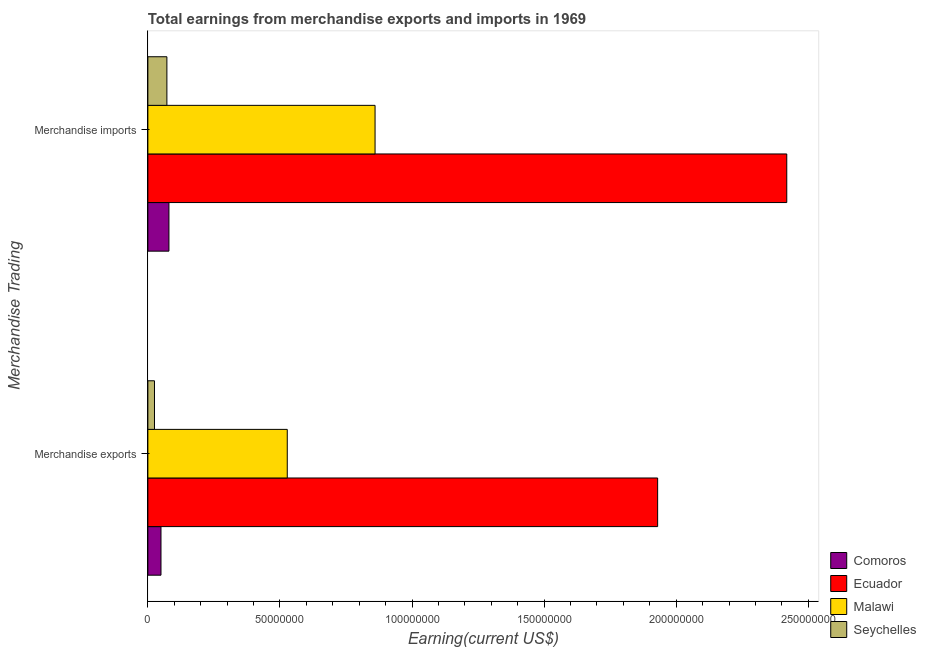How many different coloured bars are there?
Provide a short and direct response. 4. How many groups of bars are there?
Make the answer very short. 2. Are the number of bars on each tick of the Y-axis equal?
Provide a short and direct response. Yes. What is the earnings from merchandise imports in Malawi?
Provide a short and direct response. 8.60e+07. Across all countries, what is the maximum earnings from merchandise imports?
Your answer should be very brief. 2.42e+08. Across all countries, what is the minimum earnings from merchandise exports?
Offer a terse response. 2.50e+06. In which country was the earnings from merchandise imports maximum?
Ensure brevity in your answer.  Ecuador. In which country was the earnings from merchandise imports minimum?
Provide a short and direct response. Seychelles. What is the total earnings from merchandise exports in the graph?
Offer a very short reply. 2.53e+08. What is the difference between the earnings from merchandise exports in Malawi and that in Ecuador?
Provide a succinct answer. -1.40e+08. What is the difference between the earnings from merchandise imports in Ecuador and the earnings from merchandise exports in Comoros?
Provide a succinct answer. 2.37e+08. What is the average earnings from merchandise exports per country?
Offer a very short reply. 6.33e+07. What is the difference between the earnings from merchandise imports and earnings from merchandise exports in Malawi?
Ensure brevity in your answer.  3.32e+07. In how many countries, is the earnings from merchandise imports greater than 120000000 US$?
Your answer should be compact. 1. What is the ratio of the earnings from merchandise exports in Malawi to that in Comoros?
Give a very brief answer. 10.63. Is the earnings from merchandise imports in Ecuador less than that in Seychelles?
Make the answer very short. No. What does the 3rd bar from the top in Merchandise exports represents?
Your response must be concise. Ecuador. What does the 3rd bar from the bottom in Merchandise imports represents?
Provide a short and direct response. Malawi. Are all the bars in the graph horizontal?
Your answer should be very brief. Yes. What is the title of the graph?
Your answer should be very brief. Total earnings from merchandise exports and imports in 1969. Does "Hong Kong" appear as one of the legend labels in the graph?
Your answer should be very brief. No. What is the label or title of the X-axis?
Your answer should be compact. Earning(current US$). What is the label or title of the Y-axis?
Provide a succinct answer. Merchandise Trading. What is the Earning(current US$) of Comoros in Merchandise exports?
Offer a very short reply. 4.96e+06. What is the Earning(current US$) in Ecuador in Merchandise exports?
Give a very brief answer. 1.93e+08. What is the Earning(current US$) of Malawi in Merchandise exports?
Provide a succinct answer. 5.28e+07. What is the Earning(current US$) in Seychelles in Merchandise exports?
Give a very brief answer. 2.50e+06. What is the Earning(current US$) of Comoros in Merchandise imports?
Give a very brief answer. 7.97e+06. What is the Earning(current US$) of Ecuador in Merchandise imports?
Ensure brevity in your answer.  2.42e+08. What is the Earning(current US$) of Malawi in Merchandise imports?
Your response must be concise. 8.60e+07. What is the Earning(current US$) in Seychelles in Merchandise imports?
Your response must be concise. 7.20e+06. Across all Merchandise Trading, what is the maximum Earning(current US$) of Comoros?
Your answer should be very brief. 7.97e+06. Across all Merchandise Trading, what is the maximum Earning(current US$) of Ecuador?
Your answer should be very brief. 2.42e+08. Across all Merchandise Trading, what is the maximum Earning(current US$) of Malawi?
Ensure brevity in your answer.  8.60e+07. Across all Merchandise Trading, what is the maximum Earning(current US$) of Seychelles?
Provide a short and direct response. 7.20e+06. Across all Merchandise Trading, what is the minimum Earning(current US$) in Comoros?
Keep it short and to the point. 4.96e+06. Across all Merchandise Trading, what is the minimum Earning(current US$) in Ecuador?
Provide a short and direct response. 1.93e+08. Across all Merchandise Trading, what is the minimum Earning(current US$) of Malawi?
Your answer should be very brief. 5.28e+07. Across all Merchandise Trading, what is the minimum Earning(current US$) in Seychelles?
Provide a succinct answer. 2.50e+06. What is the total Earning(current US$) of Comoros in the graph?
Offer a terse response. 1.29e+07. What is the total Earning(current US$) of Ecuador in the graph?
Provide a short and direct response. 4.35e+08. What is the total Earning(current US$) of Malawi in the graph?
Give a very brief answer. 1.39e+08. What is the total Earning(current US$) in Seychelles in the graph?
Provide a succinct answer. 9.70e+06. What is the difference between the Earning(current US$) of Comoros in Merchandise exports and that in Merchandise imports?
Provide a succinct answer. -3.01e+06. What is the difference between the Earning(current US$) in Ecuador in Merchandise exports and that in Merchandise imports?
Your response must be concise. -4.89e+07. What is the difference between the Earning(current US$) in Malawi in Merchandise exports and that in Merchandise imports?
Your answer should be compact. -3.32e+07. What is the difference between the Earning(current US$) in Seychelles in Merchandise exports and that in Merchandise imports?
Provide a short and direct response. -4.70e+06. What is the difference between the Earning(current US$) of Comoros in Merchandise exports and the Earning(current US$) of Ecuador in Merchandise imports?
Give a very brief answer. -2.37e+08. What is the difference between the Earning(current US$) in Comoros in Merchandise exports and the Earning(current US$) in Malawi in Merchandise imports?
Provide a short and direct response. -8.10e+07. What is the difference between the Earning(current US$) of Comoros in Merchandise exports and the Earning(current US$) of Seychelles in Merchandise imports?
Provide a succinct answer. -2.24e+06. What is the difference between the Earning(current US$) in Ecuador in Merchandise exports and the Earning(current US$) in Malawi in Merchandise imports?
Provide a succinct answer. 1.07e+08. What is the difference between the Earning(current US$) in Ecuador in Merchandise exports and the Earning(current US$) in Seychelles in Merchandise imports?
Give a very brief answer. 1.86e+08. What is the difference between the Earning(current US$) of Malawi in Merchandise exports and the Earning(current US$) of Seychelles in Merchandise imports?
Offer a very short reply. 4.56e+07. What is the average Earning(current US$) in Comoros per Merchandise Trading?
Make the answer very short. 6.47e+06. What is the average Earning(current US$) of Ecuador per Merchandise Trading?
Your answer should be compact. 2.17e+08. What is the average Earning(current US$) of Malawi per Merchandise Trading?
Your answer should be compact. 6.94e+07. What is the average Earning(current US$) of Seychelles per Merchandise Trading?
Offer a very short reply. 4.85e+06. What is the difference between the Earning(current US$) in Comoros and Earning(current US$) in Ecuador in Merchandise exports?
Offer a very short reply. -1.88e+08. What is the difference between the Earning(current US$) in Comoros and Earning(current US$) in Malawi in Merchandise exports?
Keep it short and to the point. -4.78e+07. What is the difference between the Earning(current US$) in Comoros and Earning(current US$) in Seychelles in Merchandise exports?
Your answer should be very brief. 2.46e+06. What is the difference between the Earning(current US$) of Ecuador and Earning(current US$) of Malawi in Merchandise exports?
Offer a terse response. 1.40e+08. What is the difference between the Earning(current US$) of Ecuador and Earning(current US$) of Seychelles in Merchandise exports?
Your response must be concise. 1.90e+08. What is the difference between the Earning(current US$) in Malawi and Earning(current US$) in Seychelles in Merchandise exports?
Keep it short and to the point. 5.03e+07. What is the difference between the Earning(current US$) in Comoros and Earning(current US$) in Ecuador in Merchandise imports?
Give a very brief answer. -2.34e+08. What is the difference between the Earning(current US$) of Comoros and Earning(current US$) of Malawi in Merchandise imports?
Provide a succinct answer. -7.80e+07. What is the difference between the Earning(current US$) of Comoros and Earning(current US$) of Seychelles in Merchandise imports?
Ensure brevity in your answer.  7.73e+05. What is the difference between the Earning(current US$) of Ecuador and Earning(current US$) of Malawi in Merchandise imports?
Offer a very short reply. 1.56e+08. What is the difference between the Earning(current US$) of Ecuador and Earning(current US$) of Seychelles in Merchandise imports?
Keep it short and to the point. 2.35e+08. What is the difference between the Earning(current US$) in Malawi and Earning(current US$) in Seychelles in Merchandise imports?
Your response must be concise. 7.88e+07. What is the ratio of the Earning(current US$) in Comoros in Merchandise exports to that in Merchandise imports?
Ensure brevity in your answer.  0.62. What is the ratio of the Earning(current US$) of Ecuador in Merchandise exports to that in Merchandise imports?
Ensure brevity in your answer.  0.8. What is the ratio of the Earning(current US$) of Malawi in Merchandise exports to that in Merchandise imports?
Make the answer very short. 0.61. What is the ratio of the Earning(current US$) of Seychelles in Merchandise exports to that in Merchandise imports?
Ensure brevity in your answer.  0.35. What is the difference between the highest and the second highest Earning(current US$) in Comoros?
Your answer should be compact. 3.01e+06. What is the difference between the highest and the second highest Earning(current US$) of Ecuador?
Make the answer very short. 4.89e+07. What is the difference between the highest and the second highest Earning(current US$) of Malawi?
Your answer should be very brief. 3.32e+07. What is the difference between the highest and the second highest Earning(current US$) in Seychelles?
Give a very brief answer. 4.70e+06. What is the difference between the highest and the lowest Earning(current US$) of Comoros?
Keep it short and to the point. 3.01e+06. What is the difference between the highest and the lowest Earning(current US$) of Ecuador?
Offer a terse response. 4.89e+07. What is the difference between the highest and the lowest Earning(current US$) in Malawi?
Ensure brevity in your answer.  3.32e+07. What is the difference between the highest and the lowest Earning(current US$) in Seychelles?
Provide a succinct answer. 4.70e+06. 